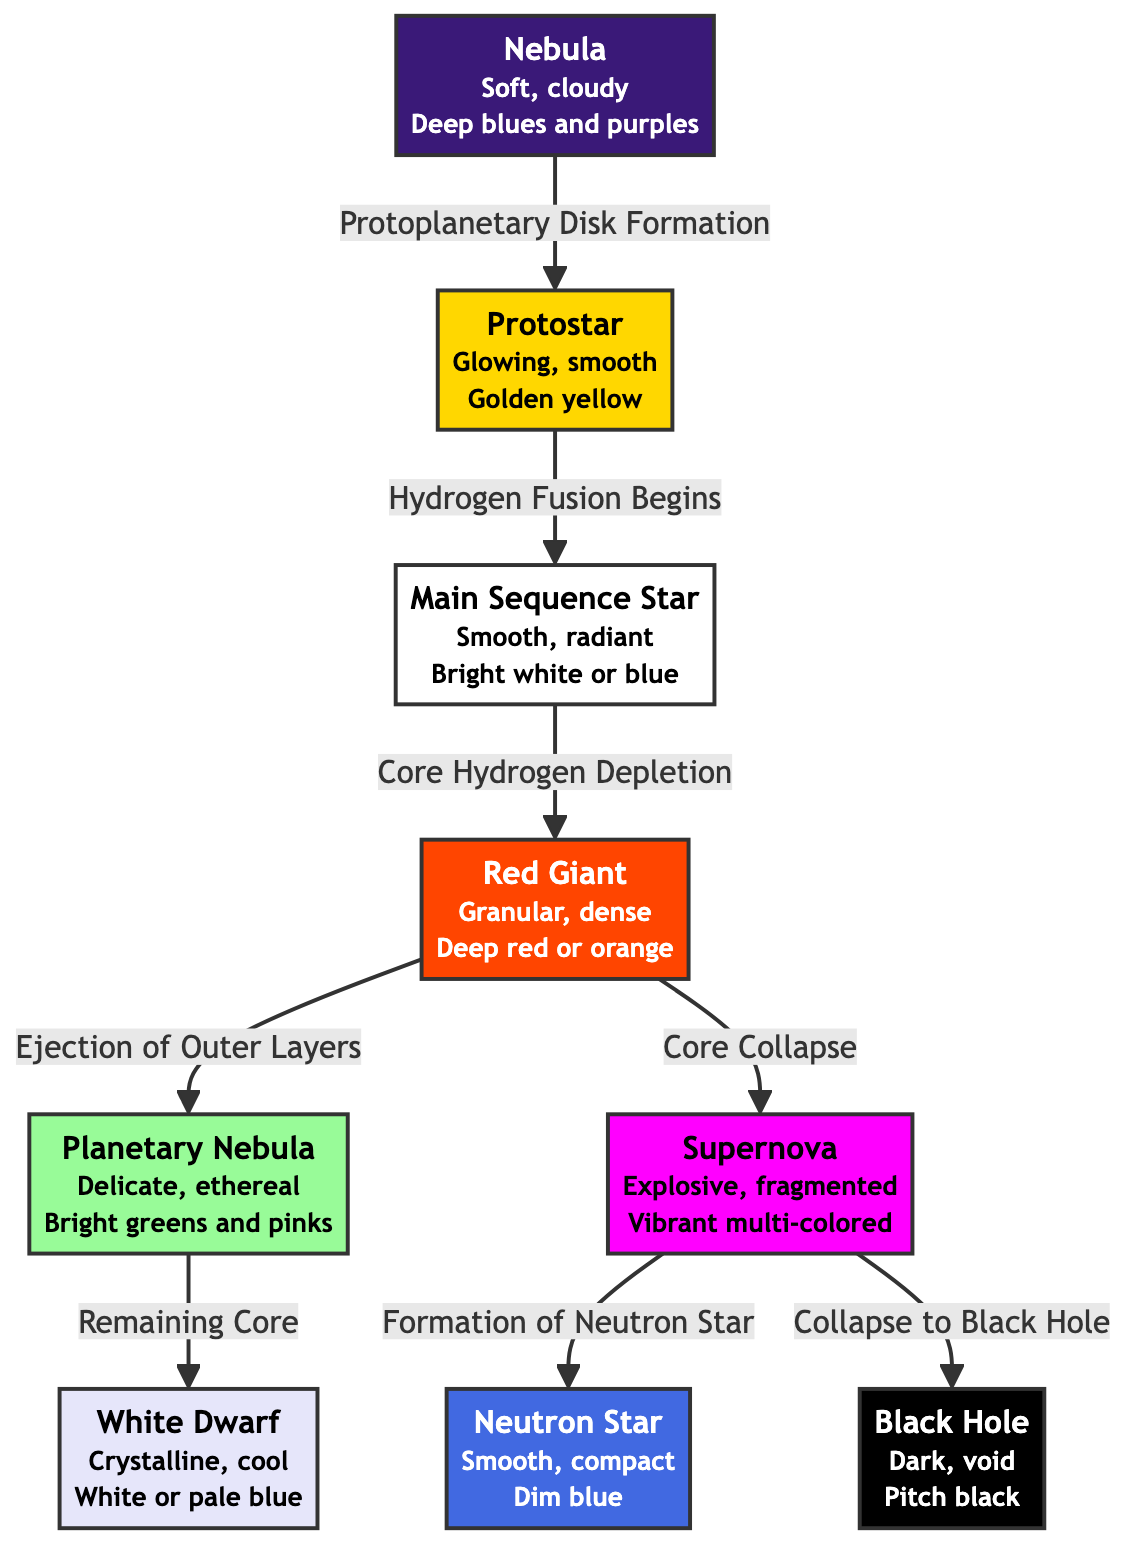What is the first stage of a star's lifecycle? The diagram shows the lifecycle of stars starting with the "Nebula" stage, indicated at the top of the flowchart.
Answer: Nebula How many main stages are there in the star lifecycle? By counting the stages represented as nodes in the flowchart, we see there are eight main stages: Nebula, Protostar, Main Sequence Star, Red Giant, Supernova, Neutron Star, Black Hole, and White Dwarf.
Answer: Eight What color describes the protostar? The description next to the "Protostar" node specifies its color as "Golden yellow".
Answer: Golden yellow What happens after the red giant stage? The flowchart indicates that after the "Red Giant," a star either ejects its outer layers to form a "Planetary Nebula" or undergoes "Core Collapse" leading to a "Supernova."
Answer: Planetary Nebula or Supernova What is the relationship between supernova and black hole? The flowchart shows a direct connection where after a "Supernova," one possible outcome is the "Collapse to Black Hole," indicating a specific transition from one state to another.
Answer: Collapse to Black Hole What kind of texture is associated with a neutron star? The diagram specifies that the texture of a "Neutron Star" is categorized as "Smooth, compact".
Answer: Smooth, compact Which stage involves the ejection of outer layers? The "Red Giant" stage is indicated to be when the outer layers are ejected, leading to the formation of a "Planetary Nebula."
Answer: Red Giant How does a star become a main sequence star? According to the diagram, a star becomes a "Main Sequence Star" when "Hydrogen Fusion Begins," which follows the "Protostar" stage.
Answer: Hydrogen Fusion Begins What is the final product of the red giant's transition? The red giant can transition into either a "Planetary Nebula" or lead to a "Supernova" depending on its core collapse, as illustrated in the diagram.
Answer: Planetary Nebula or Supernova 